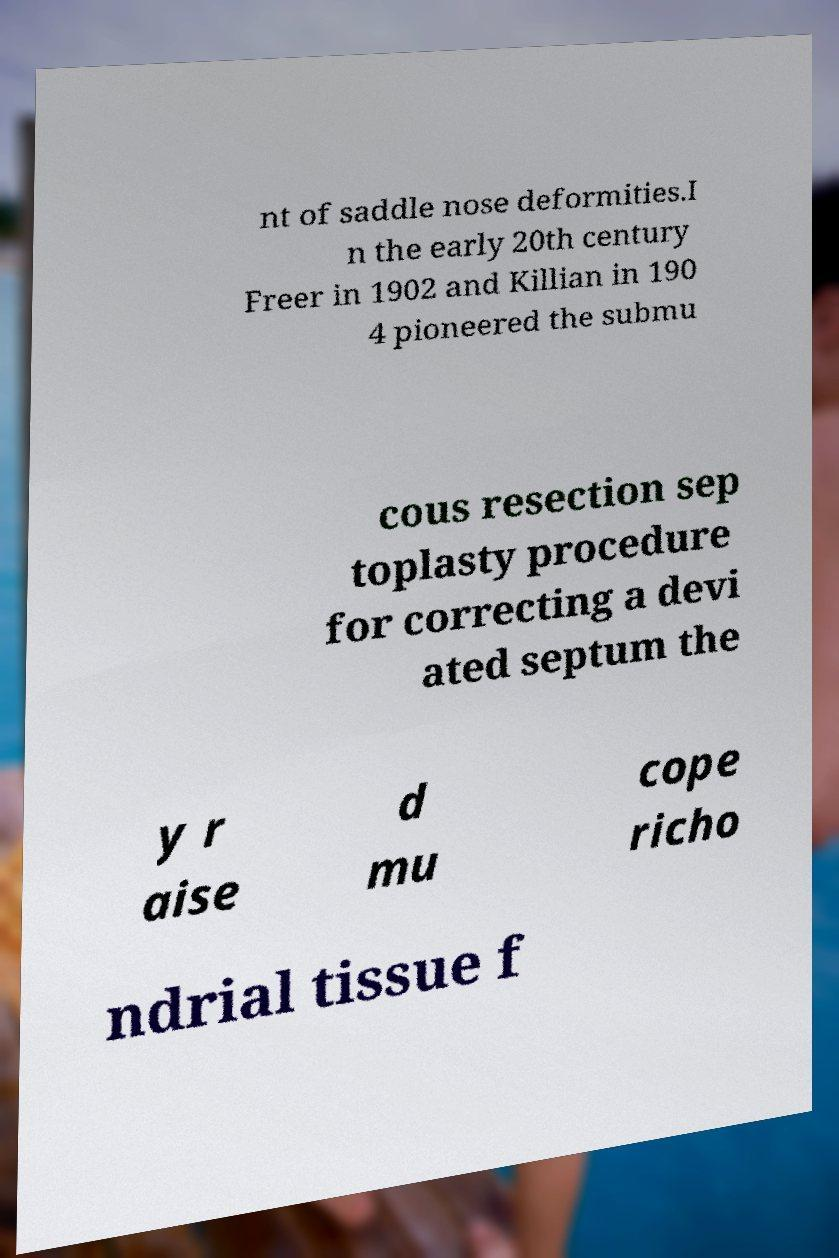Please read and relay the text visible in this image. What does it say? nt of saddle nose deformities.I n the early 20th century Freer in 1902 and Killian in 190 4 pioneered the submu cous resection sep toplasty procedure for correcting a devi ated septum the y r aise d mu cope richo ndrial tissue f 